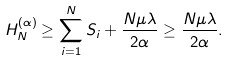Convert formula to latex. <formula><loc_0><loc_0><loc_500><loc_500>H _ { N } ^ { ( \alpha ) } \geq \sum _ { i = 1 } ^ { N } S _ { i } + \frac { N \mu \lambda } { 2 \alpha } \geq \frac { N \mu \lambda } { 2 \alpha } .</formula> 